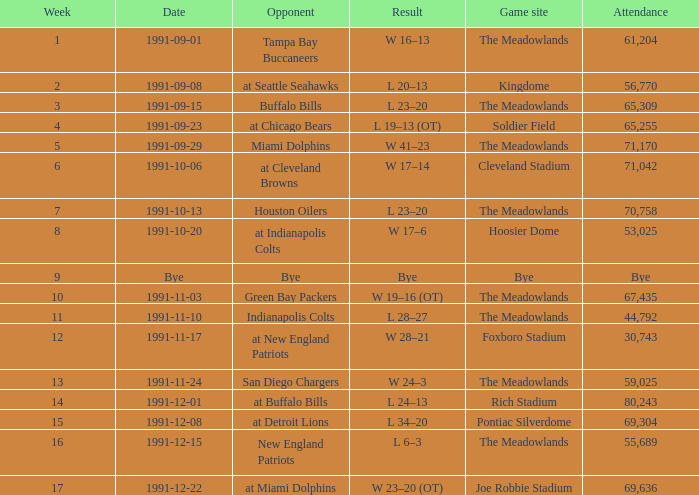What was the spectator turnout at the hoosier dome game? 53025.0. 